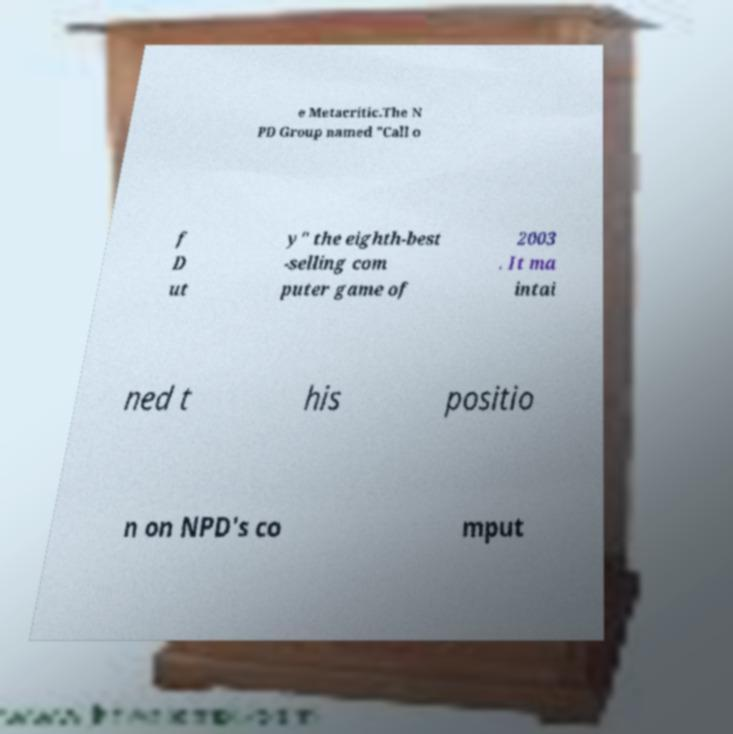Could you assist in decoding the text presented in this image and type it out clearly? e Metacritic.The N PD Group named "Call o f D ut y" the eighth-best -selling com puter game of 2003 . It ma intai ned t his positio n on NPD's co mput 